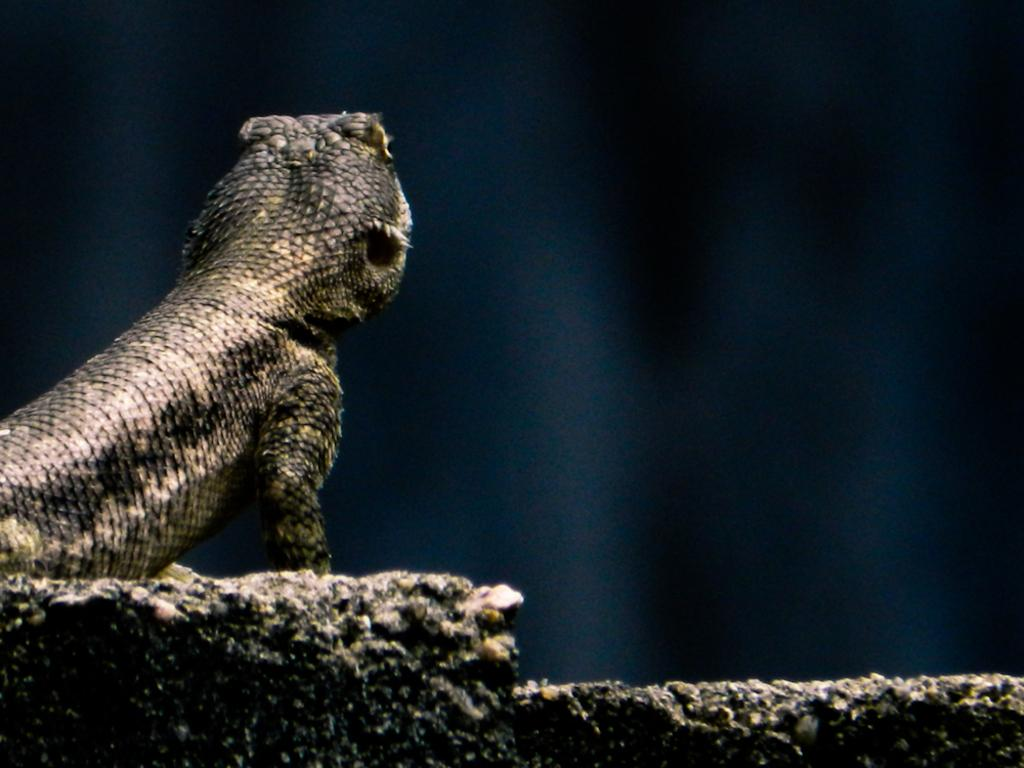What type of animal can be seen on the wall in the image? There is a lizard on the wall in the image. Can you describe the background of the image? The background of the image is blurred. What type of hook is hanging on the wall next to the lizard in the image? There is no hook present in the image; it only features a lizard on the wall. How many geese are visible in the image? There are no geese present in the image. 